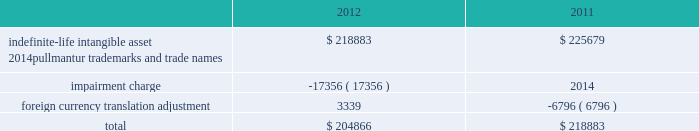Notes to the consolidated financial statements competitive environment and general economic and business conditions , among other factors .
Pullmantur is a brand targeted primarily at the spanish , portu- guese and latin american markets and although pullmantur has diversified its passenger sourcing over the past few years , spain still represents pullmantur 2019s largest market .
As previously disclosed , during 2012 european economies continued to demonstrate insta- bility in light of heightened concerns over sovereign debt issues as well as the impact of proposed auster- ity measures on certain markets .
The spanish econ- omy was more severely impacted than many other economies and there is significant uncertainty as to when it will recover .
In addition , the impact of the costa concordia incident has had a more lingering effect than expected and the impact in future years is uncertain .
These factors were identified in the past as significant risks which could lead to the impairment of pullmantur 2019s goodwill .
More recently , the spanish economy has progressively worsened and forecasts suggest the challenging operating environment will continue for an extended period of time .
The unemployment rate in spain reached 26% ( 26 % ) during the fourth quarter of 2012 and is expected to rise further in 2013 .
The international monetary fund , which had projected gdp growth of 1.8% ( 1.8 % ) a year ago , revised its 2013 gdp projections downward for spain to a contraction of 1.3% ( 1.3 % ) during the fourth quarter of 2012 and further reduced it to a contraction of 1.5% ( 1.5 % ) in january of 2013 .
During the latter half of 2012 new austerity measures , such as increases to the value added tax , cuts to benefits , the phasing out of exemptions and the suspension of government bonuses , were implemented by the spanish government .
We believe these austerity measures are having a larger impact on consumer confidence and discretionary spending than previously anticipated .
As a result , there has been a significant deterioration in bookings from guests sourced from spain during the 2013 wave season .
The combination of all of these factors has caused us to negatively adjust our cash flow projections , especially our closer-in net yield assumptions and the expectations regarding future capacity growth for the brand .
Based on our updated cash flow projections , we determined the implied fair value of goodwill for the pullmantur reporting unit was $ 145.5 million and rec- ognized an impairment charge of $ 319.2 million .
This impairment charge was recognized in earnings during the fourth quarter of 2012 and is reported within impairment of pullmantur related assets within our consolidated statements of comprehensive income ( loss ) .
There have been no goodwill impairment charges related to the pullmantur reporting unit in prior periods .
See note 13 .
Fair value measurements and derivative instruments for further discussion .
If the spanish economy weakens further or recovers more slowly than contemplated or if the economies of other markets ( e.g .
France , brazil , latin america ) perform worse than contemplated in our discounted cash flow model , or if there are material changes to the projected future cash flows used in the impair- ment analyses , especially in net yields , an additional impairment charge of the pullmantur reporting unit 2019s goodwill may be required .
Note 4 .
Intangible assets intangible assets are reported in other assets in our consolidated balance sheets and consist of the follow- ing ( in thousands ) : .
During the fourth quarter of 2012 , we performed the annual impairment review of our trademarks and trade names using a discounted cash flow model and the relief-from-royalty method .
The royalty rate used is based on comparable royalty agreements in the tourism and hospitality industry .
These trademarks and trade names relate to pullmantur and we have used a discount rate comparable to the rate used in valuing the pullmantur reporting unit in our goodwill impairment test .
As described in note 3 .
Goodwill , the continued deterioration of the spanish economy caused us to negatively adjust our cash flow projections for the pullmantur reporting unit , especially our closer-in net yield assumptions and the timing of future capacity growth for the brand .
Based on our updated cash flow projections , we determined that the fair value of pullmantur 2019s trademarks and trade names no longer exceeded their carrying value .
Accordingly , we recog- nized an impairment charge of approximately $ 17.4 million to write down trademarks and trade names to their fair value of $ 204.9 million .
This impairment charge was recognized in earnings during the fourth quarter of 2012 and is reported within impairment of pullmantur related assets within our consolidated statements of comprehensive income ( loss ) .
See note 13 .
Fair value measurements and derivative instruments for further discussion .
If the spanish economy weakens further or recovers more slowly than contemplated or if the economies of other markets ( e.g .
France , brazil , latin america ) 0494.indd 76 3/27/13 12:53 pm .
What is the average of intangible assets from 2011-2012 , in thousands? 
Computations: ((204866 + 218883) / 2)
Answer: 211874.5. 